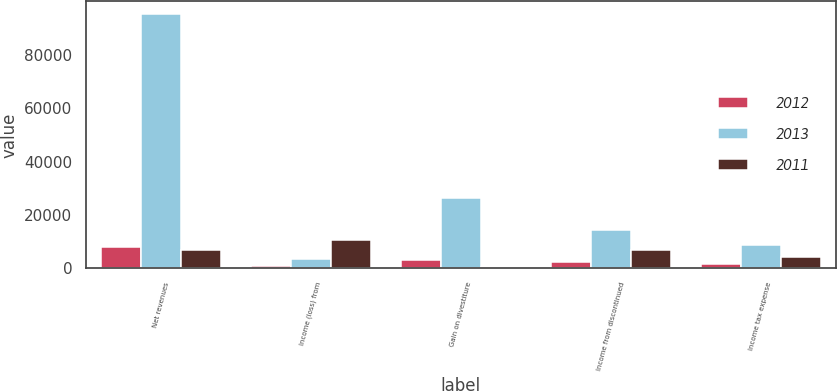Convert chart. <chart><loc_0><loc_0><loc_500><loc_500><stacked_bar_chart><ecel><fcel>Net revenues<fcel>Income (loss) from<fcel>Gain on divestiture<fcel>Income from discontinued<fcel>Income tax expense<nl><fcel>2012<fcel>7813<fcel>932<fcel>3080<fcel>2506<fcel>1506<nl><fcel>2013<fcel>95226<fcel>3472<fcel>26419<fcel>14259<fcel>8688<nl><fcel>2011<fcel>6751<fcel>10422<fcel>442<fcel>6751<fcel>4113<nl></chart> 